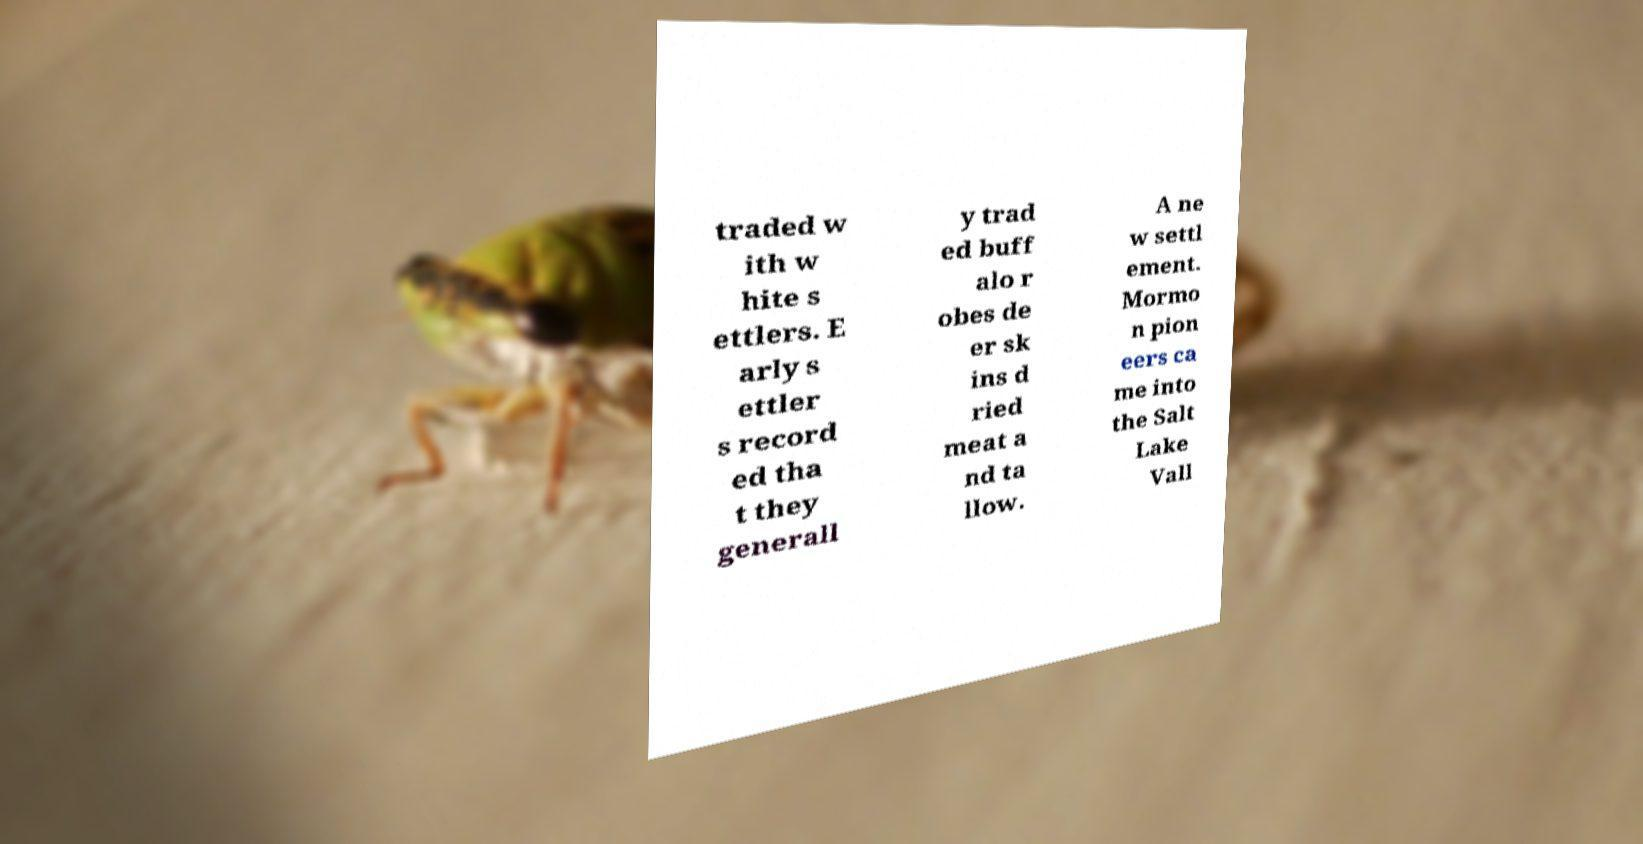There's text embedded in this image that I need extracted. Can you transcribe it verbatim? traded w ith w hite s ettlers. E arly s ettler s record ed tha t they generall y trad ed buff alo r obes de er sk ins d ried meat a nd ta llow. A ne w settl ement. Mormo n pion eers ca me into the Salt Lake Vall 